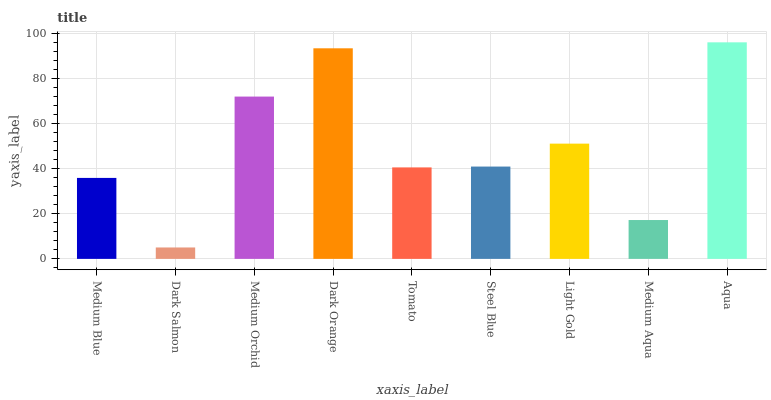Is Dark Salmon the minimum?
Answer yes or no. Yes. Is Aqua the maximum?
Answer yes or no. Yes. Is Medium Orchid the minimum?
Answer yes or no. No. Is Medium Orchid the maximum?
Answer yes or no. No. Is Medium Orchid greater than Dark Salmon?
Answer yes or no. Yes. Is Dark Salmon less than Medium Orchid?
Answer yes or no. Yes. Is Dark Salmon greater than Medium Orchid?
Answer yes or no. No. Is Medium Orchid less than Dark Salmon?
Answer yes or no. No. Is Steel Blue the high median?
Answer yes or no. Yes. Is Steel Blue the low median?
Answer yes or no. Yes. Is Tomato the high median?
Answer yes or no. No. Is Light Gold the low median?
Answer yes or no. No. 